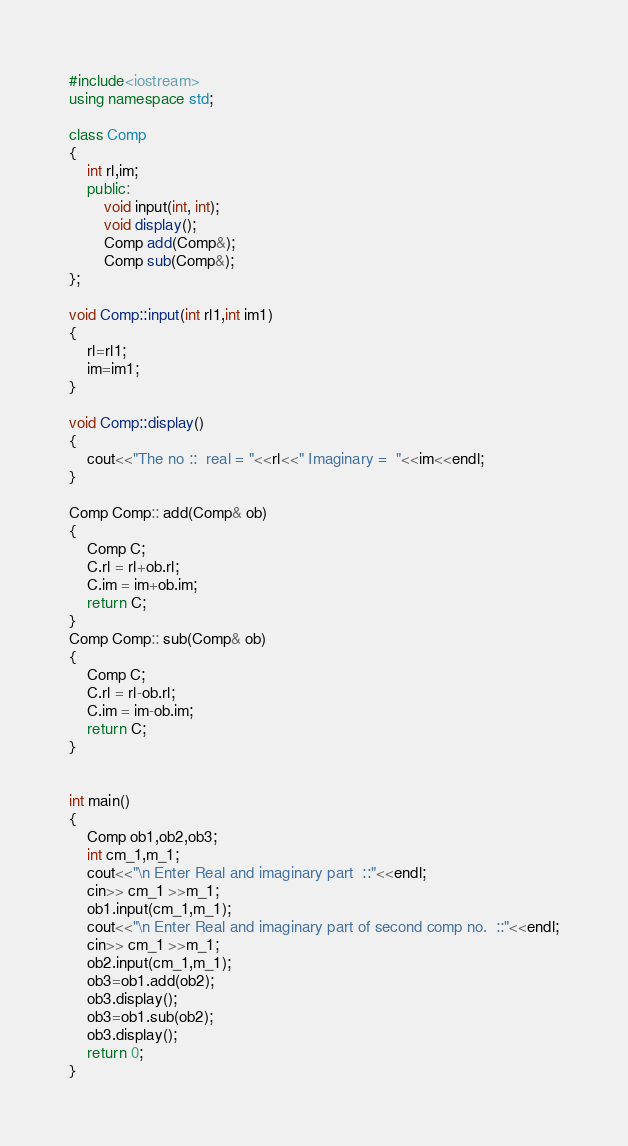<code> <loc_0><loc_0><loc_500><loc_500><_C++_>#include<iostream>
using namespace std;

class Comp
{
	int rl,im;
	public:
		void input(int, int);
		void display();
		Comp add(Comp&);
		Comp sub(Comp&);
};

void Comp::input(int rl1,int im1)
{
	rl=rl1;
	im=im1;
}

void Comp::display()
{
	cout<<"The no ::  real = "<<rl<<" Imaginary =  "<<im<<endl;
}

Comp Comp:: add(Comp& ob)
{
	Comp C;
	C.rl = rl+ob.rl;
	C.im = im+ob.im;	
	return C;
}
Comp Comp:: sub(Comp& ob)
{
	Comp C;
	C.rl = rl-ob.rl;
	C.im = im-ob.im;	
	return C;
}


int main()
{
	Comp ob1,ob2,ob3;
	int cm_1,m_1;
	cout<<"\n Enter Real and imaginary part  ::"<<endl;
	cin>> cm_1 >>m_1;
	ob1.input(cm_1,m_1);
	cout<<"\n Enter Real and imaginary part of second comp no.  ::"<<endl;
	cin>> cm_1 >>m_1;
	ob2.input(cm_1,m_1);
	ob3=ob1.add(ob2);
	ob3.display();
	ob3=ob1.sub(ob2);
	ob3.display();
	return 0;
}






</code> 